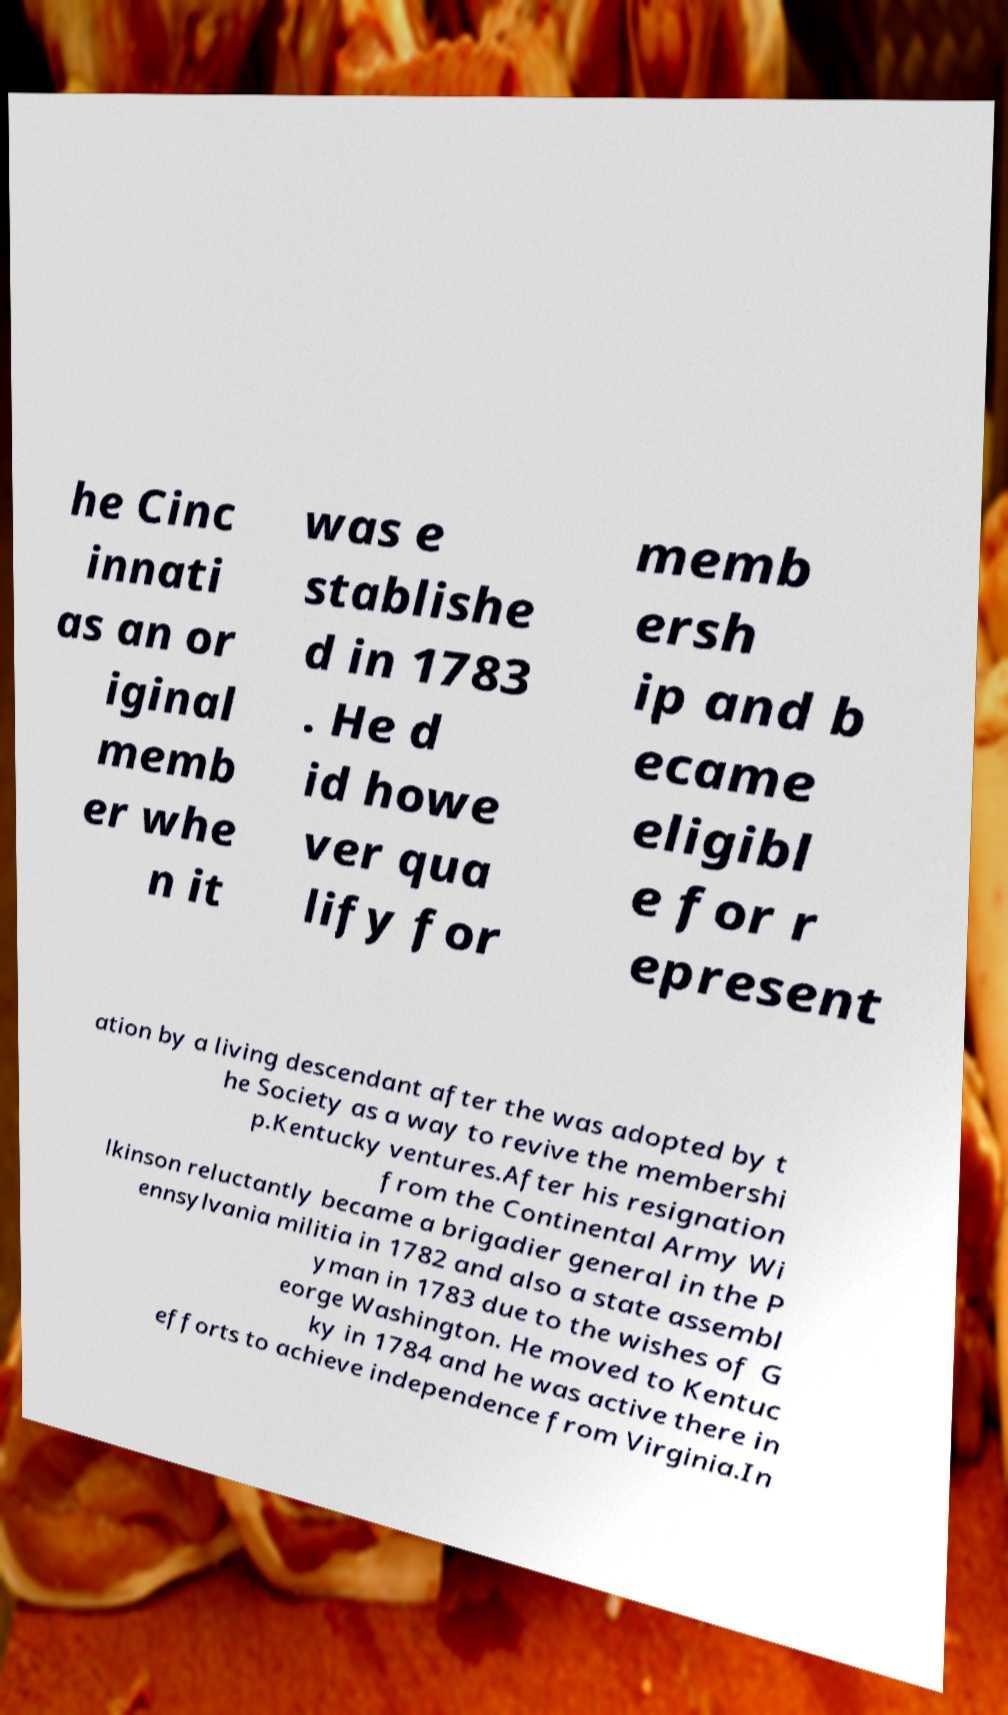Could you extract and type out the text from this image? he Cinc innati as an or iginal memb er whe n it was e stablishe d in 1783 . He d id howe ver qua lify for memb ersh ip and b ecame eligibl e for r epresent ation by a living descendant after the was adopted by t he Society as a way to revive the membershi p.Kentucky ventures.After his resignation from the Continental Army Wi lkinson reluctantly became a brigadier general in the P ennsylvania militia in 1782 and also a state assembl yman in 1783 due to the wishes of G eorge Washington. He moved to Kentuc ky in 1784 and he was active there in efforts to achieve independence from Virginia.In 